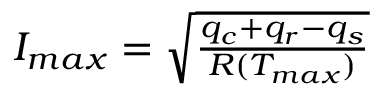<formula> <loc_0><loc_0><loc_500><loc_500>\begin{array} { r } { I _ { \max } = \sqrt { \frac { q _ { c } + q _ { r } - q _ { s } } { R ( T _ { \max } ) } } } \end{array}</formula> 